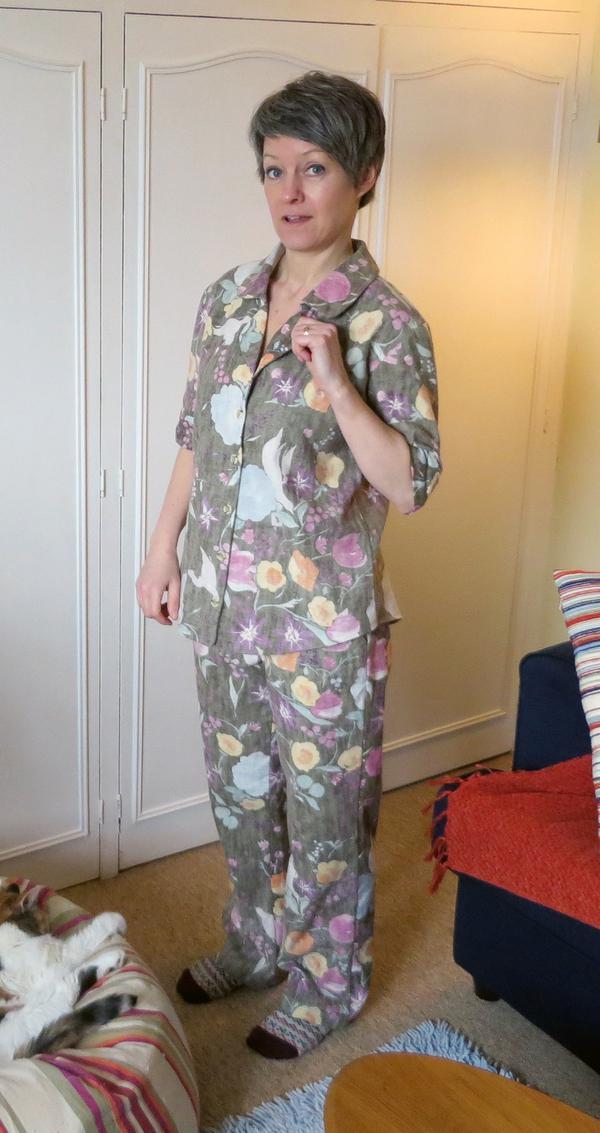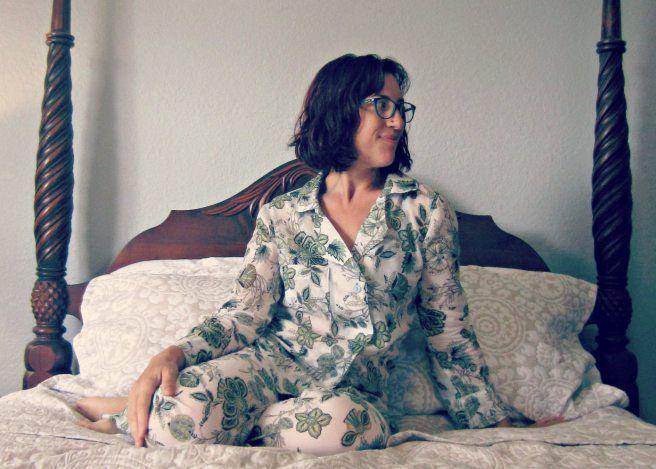The first image is the image on the left, the second image is the image on the right. For the images displayed, is the sentence "A plant stands in the corner behind and to the left of a woman standing with hands in her pockets." factually correct? Answer yes or no. No. The first image is the image on the left, the second image is the image on the right. Evaluate the accuracy of this statement regarding the images: "One image shows sleepwear displayed flat on a surface, instead of modeled by a person.". Is it true? Answer yes or no. No. 